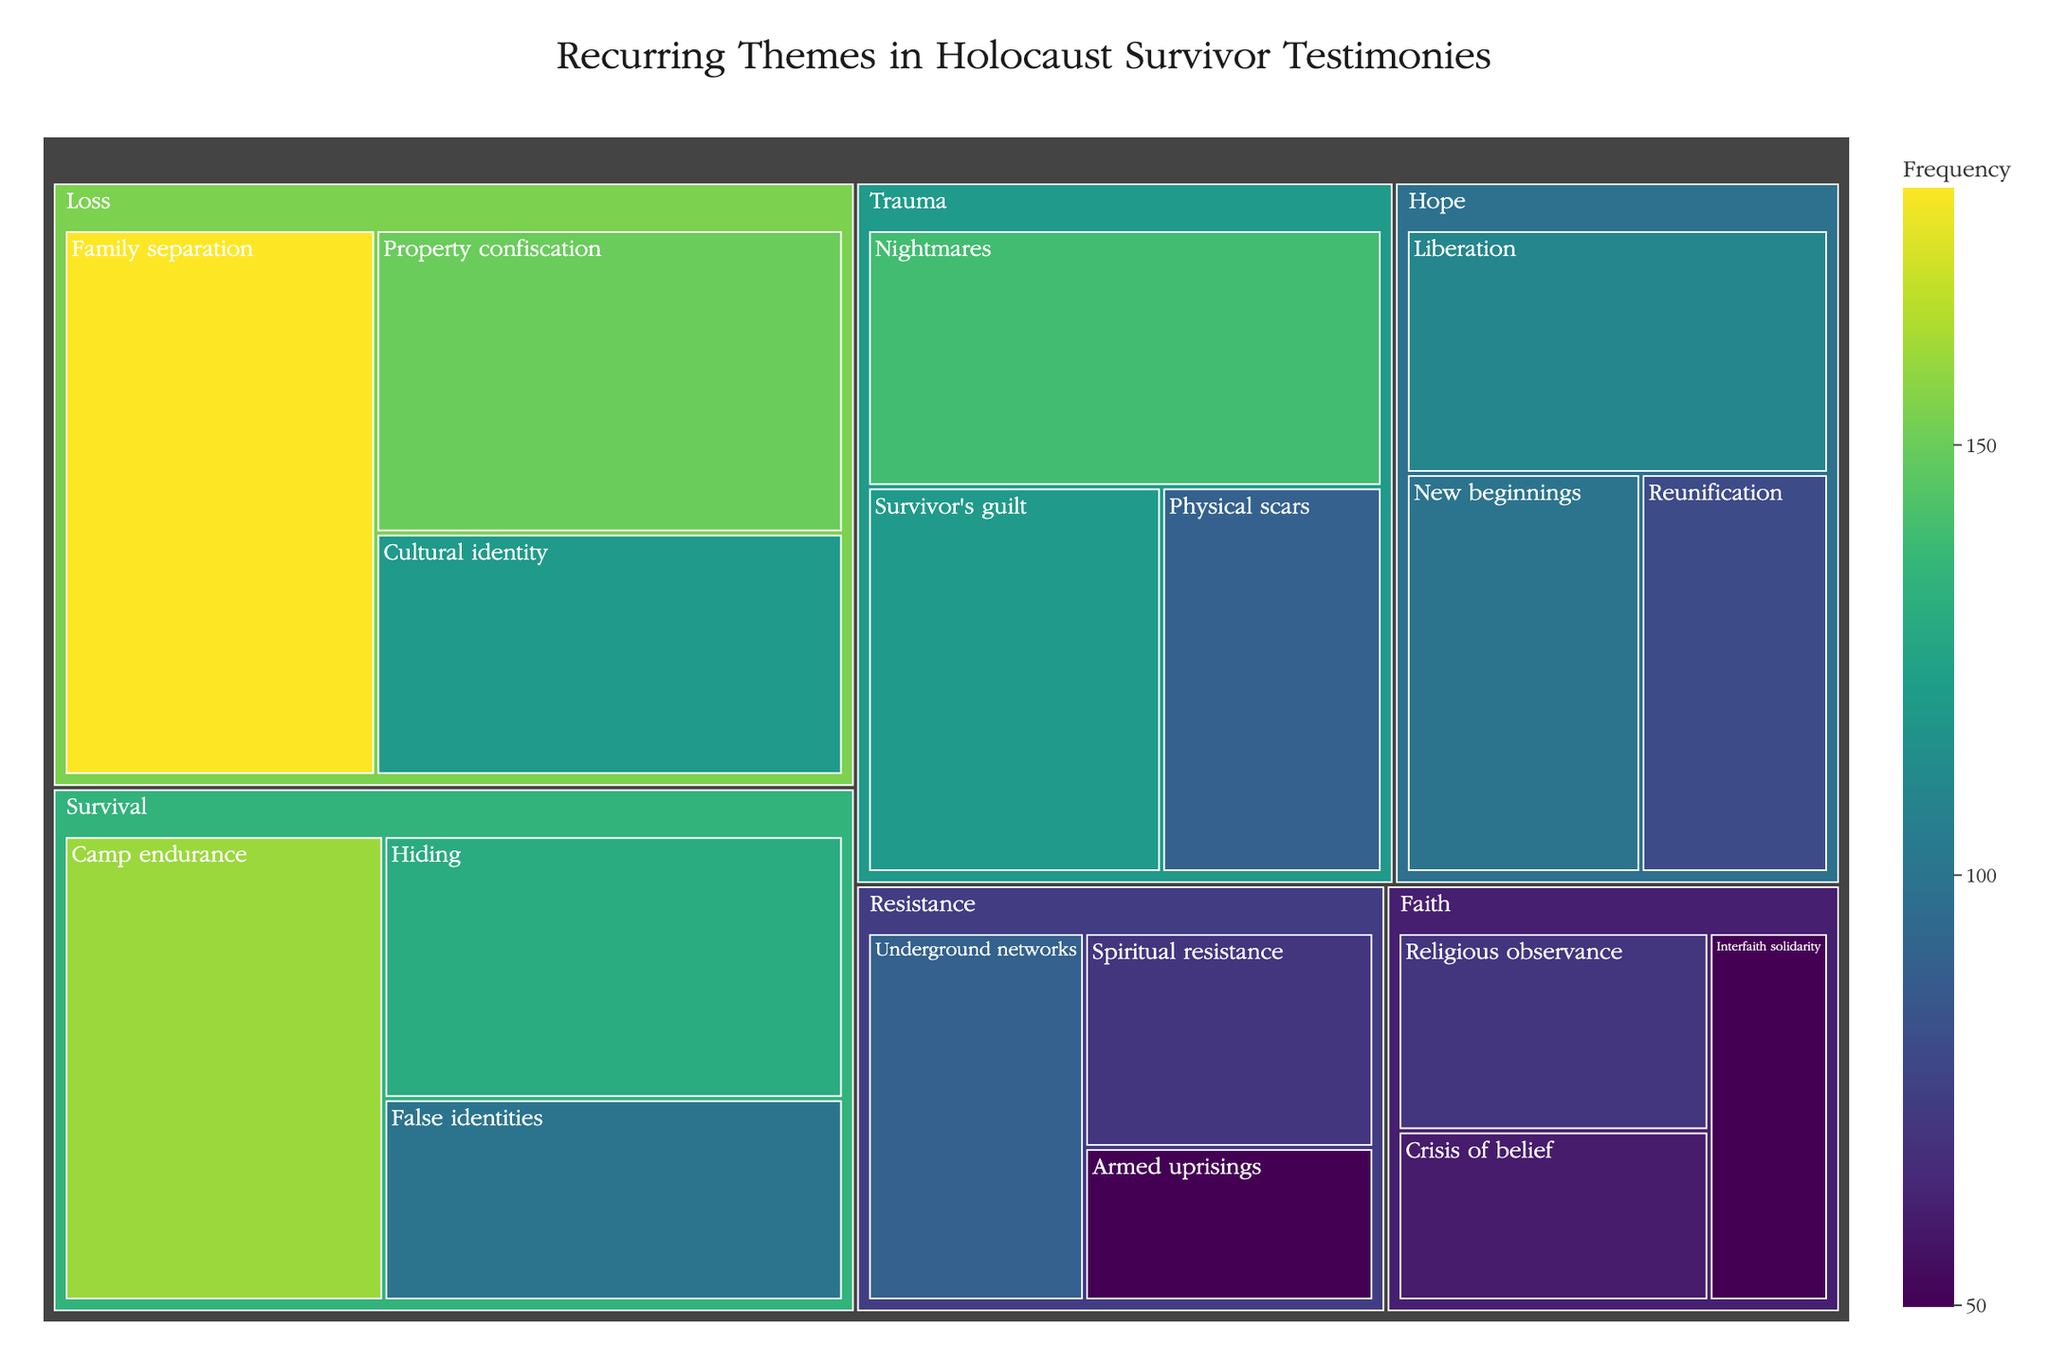What's the title of the plot? The title of the plot is usually found at the top of the figure and provides a summary of what the data represents.
Answer: Recurring Themes in Holocaust Survivor Testimonies Which category under the "Loss" theme has the highest frequency? To find this, look at all categories under "Loss" and identify the one with the highest numerical value. Family separation is the highest with 180.
Answer: Family separation What is the combined frequency of all "Hope" categories? Add the frequency values for all the "Hope" categories: Liberation (110), Reunification (80), and New beginnings (100). The sum is 110 + 80 + 100 = 290.
Answer: 290 Which theme has the second highest total frequency? To find this, sum the frequency values of all themes: Loss (450), Resistance (210), Hope (290), Survival (390), Trauma (350), Faith (180). "Survival" has the total of 390, making it the second highest after "Loss" (450).
Answer: Survival Between "Trauma" and "Faith", which has the higher frequency for their highest individual category? Compare the highest frequency values from "Trauma" (Nightmares, 140) with those from "Faith" (Religious observance, 70). "Trauma" has a higher individual category frequency.
Answer: Trauma What is the average frequency of the categories under the "Resistance" theme? Add the frequencies of Resistance categories: Underground networks (90), Spiritual resistance (70), and Armed uprisings (50), then divide by the number of categories: (90 + 70 + 50) / 3 = 210 / 3 = 70.
Answer: 70 Which category under "Survival" has the lowest frequency? Identify the smallest frequency value among the "Survival" categories: Hiding (130), False identities (100), and Camp endurance (160). "False identities" has the lowest frequency.
Answer: False identities What is the frequency range of the "Trauma" categories? Identify the smallest (Physical scars - 90) and largest (Nightmares - 140) values and calculate the range: 140 - 90 = 50.
Answer: 50 How many categories have a frequency of 100 or more under the "Hope" theme? Check each "Hope" category to see if its frequency is 100 or greater: Liberation (110), Reunification (80), and New beginnings (100). There are 2 categories (Liberation and New beginnings).
Answer: 2 Which theme has the lowest combined frequency? Sum the frequency values for each theme: Loss (450), Resistance (210), Hope (290), Survival (390), Trauma (350), and Faith (180). "Faith" has the lowest total of 180.
Answer: Faith 